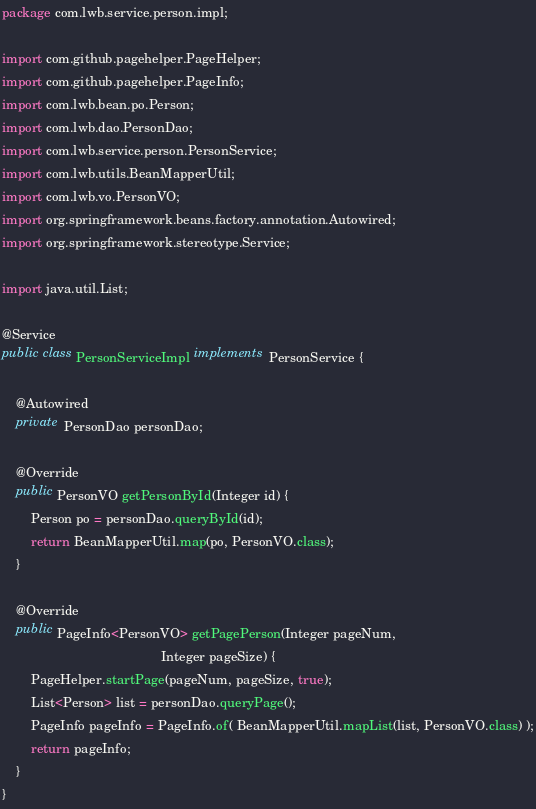Convert code to text. <code><loc_0><loc_0><loc_500><loc_500><_Java_>package com.lwb.service.person.impl;

import com.github.pagehelper.PageHelper;
import com.github.pagehelper.PageInfo;
import com.lwb.bean.po.Person;
import com.lwb.dao.PersonDao;
import com.lwb.service.person.PersonService;
import com.lwb.utils.BeanMapperUtil;
import com.lwb.vo.PersonVO;
import org.springframework.beans.factory.annotation.Autowired;
import org.springframework.stereotype.Service;

import java.util.List;

@Service
public class PersonServiceImpl implements PersonService {

    @Autowired
    private PersonDao personDao;

    @Override
    public PersonVO getPersonById(Integer id) {
        Person po = personDao.queryById(id);
        return BeanMapperUtil.map(po, PersonVO.class);
    }

    @Override
    public PageInfo<PersonVO> getPagePerson(Integer pageNum,
                                            Integer pageSize) {
        PageHelper.startPage(pageNum, pageSize, true);
        List<Person> list = personDao.queryPage();
        PageInfo pageInfo = PageInfo.of( BeanMapperUtil.mapList(list, PersonVO.class) );
        return pageInfo;
    }
}
</code> 